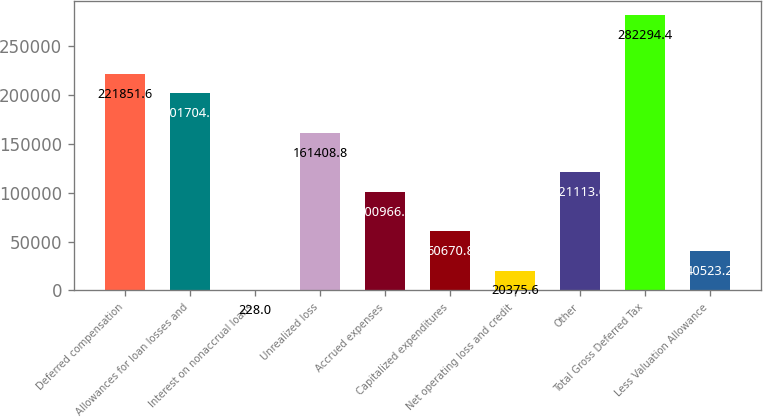Convert chart. <chart><loc_0><loc_0><loc_500><loc_500><bar_chart><fcel>Deferred compensation<fcel>Allowances for loan losses and<fcel>Interest on nonaccrual loans<fcel>Unrealized loss<fcel>Accrued expenses<fcel>Capitalized expenditures<fcel>Net operating loss and credit<fcel>Other<fcel>Total Gross Deferred Tax<fcel>Less Valuation Allowance<nl><fcel>221852<fcel>201704<fcel>228<fcel>161409<fcel>100966<fcel>60670.8<fcel>20375.6<fcel>121114<fcel>282294<fcel>40523.2<nl></chart> 